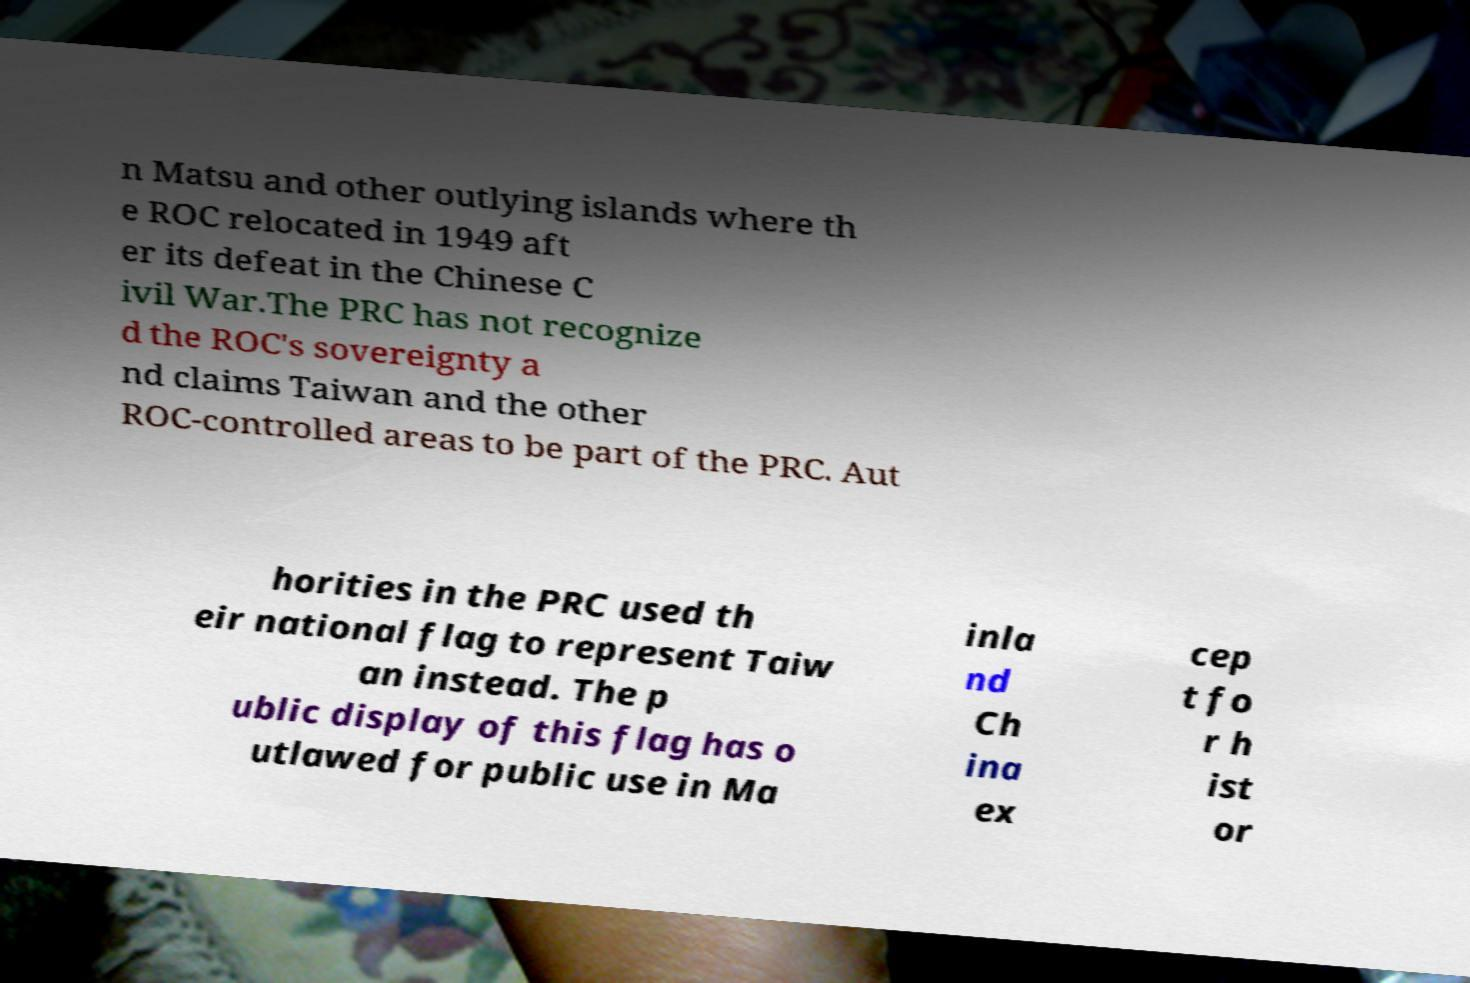Please read and relay the text visible in this image. What does it say? n Matsu and other outlying islands where th e ROC relocated in 1949 aft er its defeat in the Chinese C ivil War.The PRC has not recognize d the ROC's sovereignty a nd claims Taiwan and the other ROC-controlled areas to be part of the PRC. Aut horities in the PRC used th eir national flag to represent Taiw an instead. The p ublic display of this flag has o utlawed for public use in Ma inla nd Ch ina ex cep t fo r h ist or 